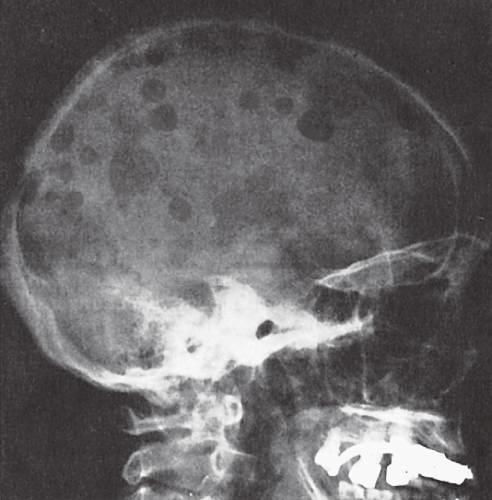what are most obvious in the calvaria?
Answer the question using a single word or phrase. The sharply punched-out bone defects 